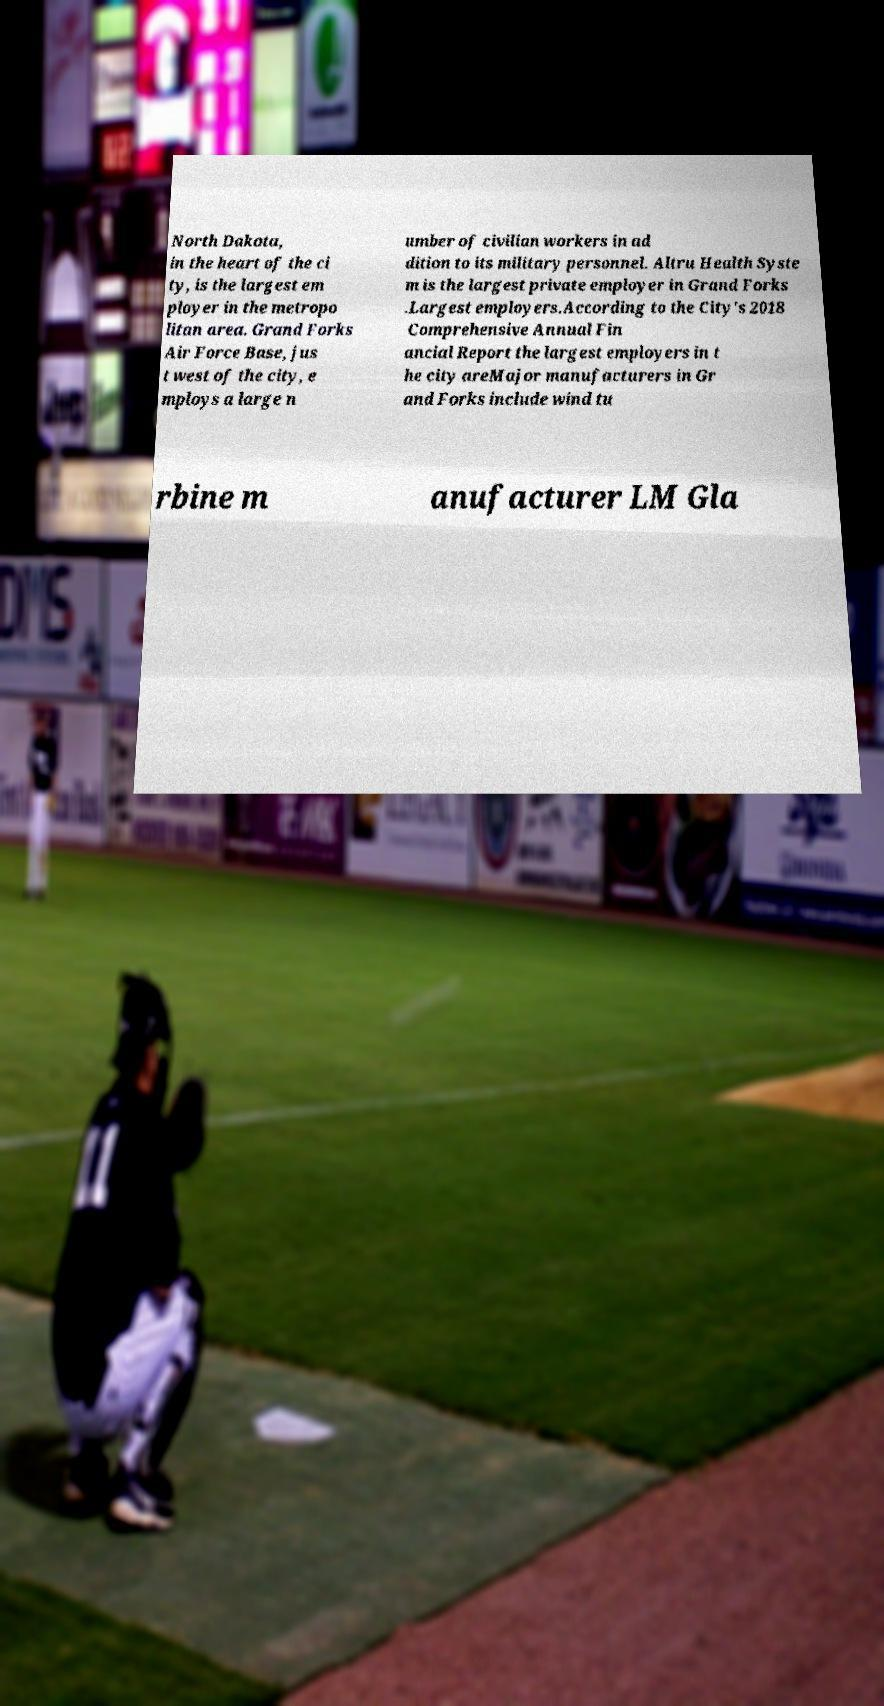There's text embedded in this image that I need extracted. Can you transcribe it verbatim? North Dakota, in the heart of the ci ty, is the largest em ployer in the metropo litan area. Grand Forks Air Force Base, jus t west of the city, e mploys a large n umber of civilian workers in ad dition to its military personnel. Altru Health Syste m is the largest private employer in Grand Forks .Largest employers.According to the City's 2018 Comprehensive Annual Fin ancial Report the largest employers in t he city areMajor manufacturers in Gr and Forks include wind tu rbine m anufacturer LM Gla 